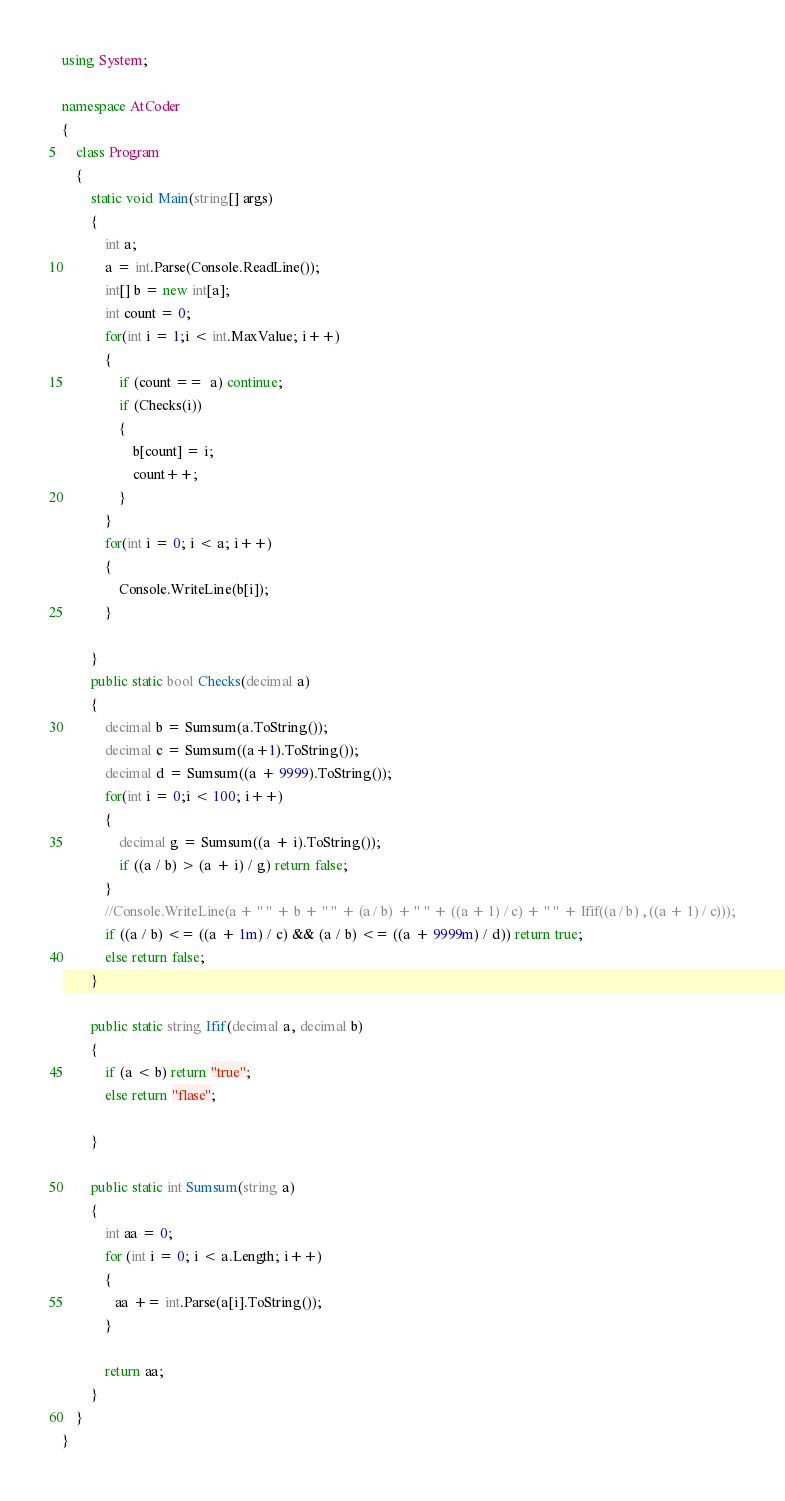Convert code to text. <code><loc_0><loc_0><loc_500><loc_500><_C#_>using System;

namespace AtCoder
{
    class Program
    {
        static void Main(string[] args)
        {
            int a;
            a = int.Parse(Console.ReadLine());
            int[] b = new int[a];
            int count = 0;
            for(int i = 1;i < int.MaxValue; i++)
            {
                if (count ==  a) continue;
                if (Checks(i))
                {
                    b[count] = i;
                    count++;
                }
            }
            for(int i = 0; i < a; i++)
            {
                Console.WriteLine(b[i]);
            }

        }
        public static bool Checks(decimal a)
        {
            decimal b = Sumsum(a.ToString());
            decimal c = Sumsum((a+1).ToString());
            decimal d = Sumsum((a + 9999).ToString());
            for(int i = 0;i < 100; i++)
            {
                decimal g = Sumsum((a + i).ToString());
                if ((a / b) > (a + i) / g) return false;
            }
            //Console.WriteLine(a + " " + b + " " + (a / b) + " " + ((a + 1) / c) + " " + Ifif((a / b) , ((a + 1) / c)));
            if ((a / b) <= ((a + 1m) / c) && (a / b) <= ((a + 9999m) / d)) return true;
            else return false;
        }
        
        public static string Ifif(decimal a, decimal b)
        {
            if (a < b) return "true";
            else return "flase";

        }

        public static int Sumsum(string a)
        {
            int aa = 0;
            for (int i = 0; i < a.Length; i++)
            {
               aa += int.Parse(a[i].ToString());
            }

            return aa;
        }
    }
}
</code> 